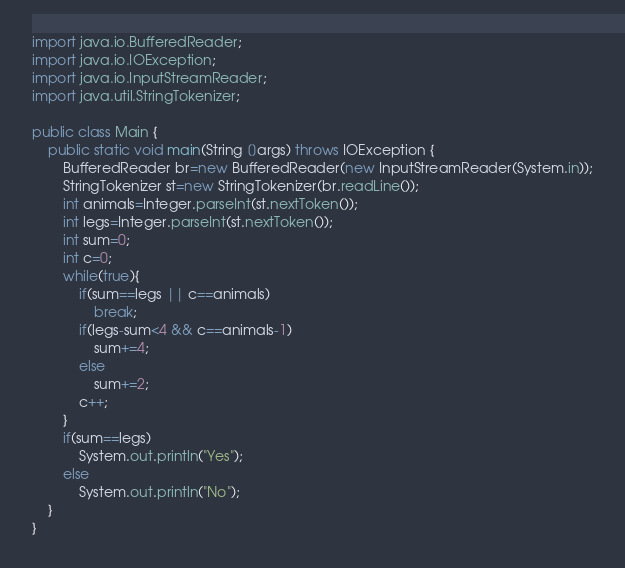Convert code to text. <code><loc_0><loc_0><loc_500><loc_500><_Java_>import java.io.BufferedReader;
import java.io.IOException;
import java.io.InputStreamReader;
import java.util.StringTokenizer;

public class Main {
    public static void main(String []args) throws IOException {
        BufferedReader br=new BufferedReader(new InputStreamReader(System.in));
        StringTokenizer st=new StringTokenizer(br.readLine());
        int animals=Integer.parseInt(st.nextToken());
        int legs=Integer.parseInt(st.nextToken());
        int sum=0;
        int c=0;
        while(true){
            if(sum==legs || c==animals)
                break;
            if(legs-sum<4 && c==animals-1)
                sum+=4;
            else
                sum+=2;
            c++;
        }
        if(sum==legs)
            System.out.println("Yes");
        else
            System.out.println("No");
    }
}
</code> 